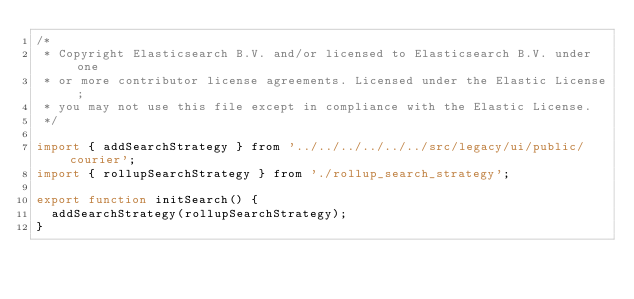Convert code to text. <code><loc_0><loc_0><loc_500><loc_500><_JavaScript_>/*
 * Copyright Elasticsearch B.V. and/or licensed to Elasticsearch B.V. under one
 * or more contributor license agreements. Licensed under the Elastic License;
 * you may not use this file except in compliance with the Elastic License.
 */

import { addSearchStrategy } from '../../../../../../src/legacy/ui/public/courier';
import { rollupSearchStrategy } from './rollup_search_strategy';

export function initSearch() {
  addSearchStrategy(rollupSearchStrategy);
}
</code> 